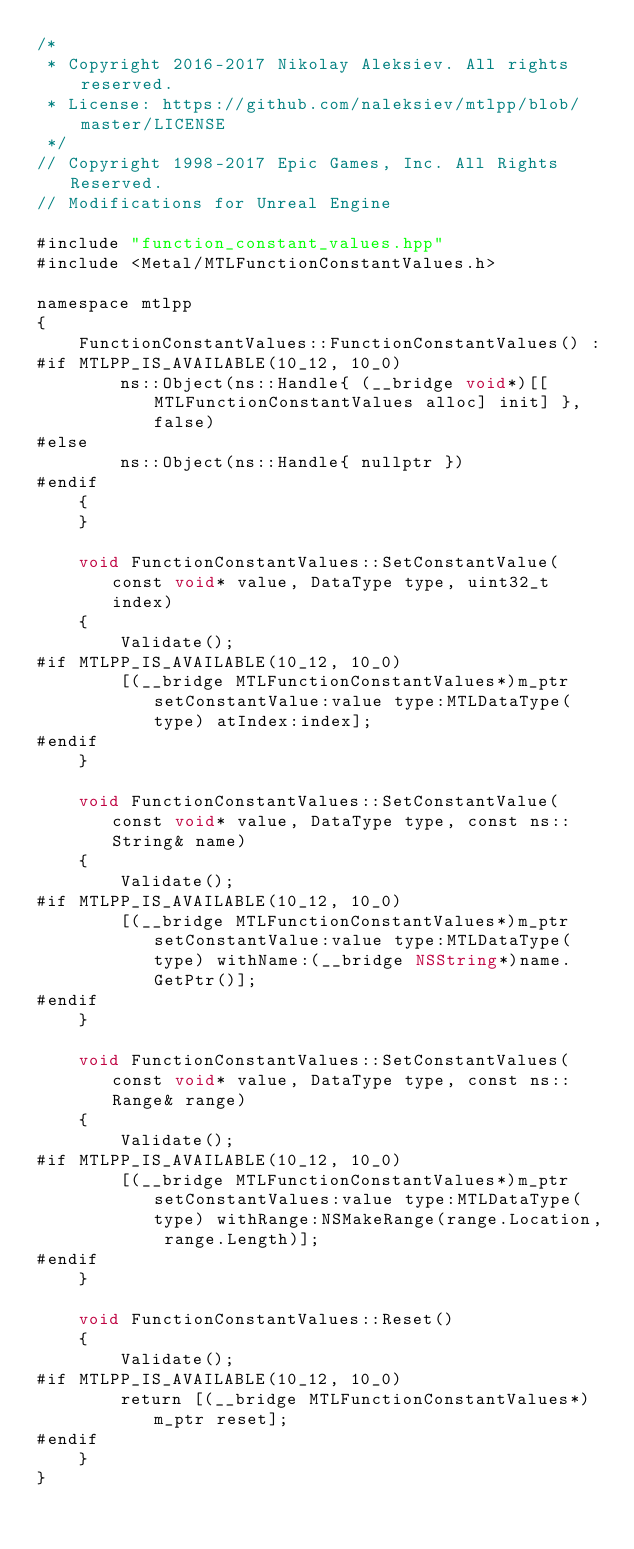Convert code to text. <code><loc_0><loc_0><loc_500><loc_500><_ObjectiveC_>/*
 * Copyright 2016-2017 Nikolay Aleksiev. All rights reserved.
 * License: https://github.com/naleksiev/mtlpp/blob/master/LICENSE
 */
// Copyright 1998-2017 Epic Games, Inc. All Rights Reserved.
// Modifications for Unreal Engine

#include "function_constant_values.hpp"
#include <Metal/MTLFunctionConstantValues.h>

namespace mtlpp
{
    FunctionConstantValues::FunctionConstantValues() :
#if MTLPP_IS_AVAILABLE(10_12, 10_0)
        ns::Object(ns::Handle{ (__bridge void*)[[MTLFunctionConstantValues alloc] init] }, false)
#else
        ns::Object(ns::Handle{ nullptr })
#endif
    {
    }

    void FunctionConstantValues::SetConstantValue(const void* value, DataType type, uint32_t index)
    {
        Validate();
#if MTLPP_IS_AVAILABLE(10_12, 10_0)
        [(__bridge MTLFunctionConstantValues*)m_ptr setConstantValue:value type:MTLDataType(type) atIndex:index];
#endif
    }

    void FunctionConstantValues::SetConstantValue(const void* value, DataType type, const ns::String& name)
    {
        Validate();
#if MTLPP_IS_AVAILABLE(10_12, 10_0)
        [(__bridge MTLFunctionConstantValues*)m_ptr setConstantValue:value type:MTLDataType(type) withName:(__bridge NSString*)name.GetPtr()];
#endif
    }

    void FunctionConstantValues::SetConstantValues(const void* value, DataType type, const ns::Range& range)
    {
        Validate();
#if MTLPP_IS_AVAILABLE(10_12, 10_0)
        [(__bridge MTLFunctionConstantValues*)m_ptr setConstantValues:value type:MTLDataType(type) withRange:NSMakeRange(range.Location, range.Length)];
#endif
    }

    void FunctionConstantValues::Reset()
    {
        Validate();
#if MTLPP_IS_AVAILABLE(10_12, 10_0)
        return [(__bridge MTLFunctionConstantValues*)m_ptr reset];
#endif
    }
}
</code> 